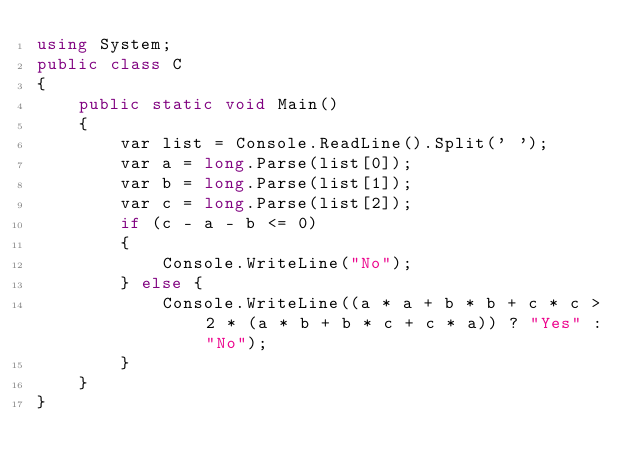<code> <loc_0><loc_0><loc_500><loc_500><_C#_>using System;
public class C
{
    public static void Main()
    {
        var list = Console.ReadLine().Split(' ');
        var a = long.Parse(list[0]);
        var b = long.Parse(list[1]);
        var c = long.Parse(list[2]);
        if (c - a - b <= 0)
        {
            Console.WriteLine("No");
        } else {
            Console.WriteLine((a * a + b * b + c * c > 2 * (a * b + b * c + c * a)) ? "Yes" : "No");
        }
    }
}</code> 